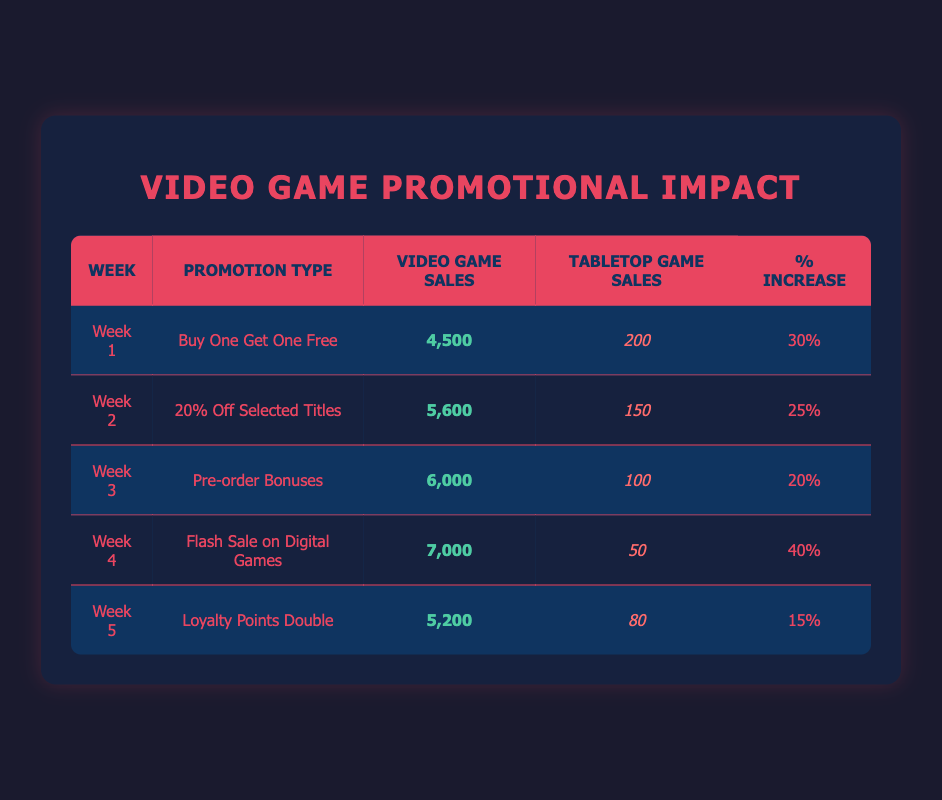What was the highest video game sales recorded during the promotional weeks? The highest video game sales can be found by examining the "Video Game Sales" column. The highest value listed is 7,000 from Week 4, which corresponds to the "Flash Sale on Digital Games" promotion.
Answer: 7,000 Which week's promotion resulted in the largest percentage increase in video game sales? To determine this, we look at the "% Increase" column. The highest percentage listed is 40% for Week 4 (Flash Sale on Digital Games).
Answer: 40% What were the total video game sales across all the weeks? To find the total, we sum the "Video Game Sales" values: 4,500 + 5,600 + 6,000 + 7,000 + 5,200 = 28,300.
Answer: 28,300 Did the "Buy One Get One Free" promotion lead to more tabletop game sales compared to the "Loyalty Points Double" promotion? The tabletop game sales for "Buy One Get One Free" in Week 1 were 200, while for "Loyalty Points Double" in Week 5, they were 80. Since 200 is greater than 80, the statement is true.
Answer: Yes What is the average percentage increase in sales during the promotional weeks? We calculate the average by summing the "% Increase" values (30 + 25 + 20 + 40 + 15) = 130, and then dividing by the number of weeks (5): 130 / 5 = 26.
Answer: 26 